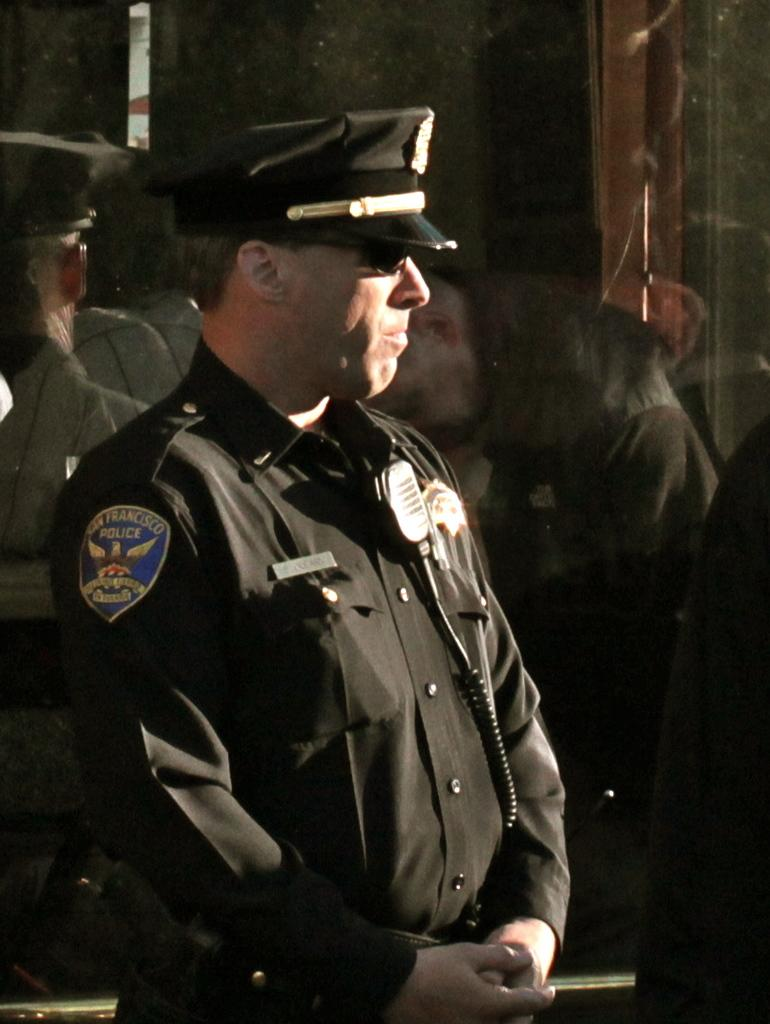Who is the main subject in the image? There is a person in the center of the image. What is the person wearing? The person is wearing a uniform. What is the person's posture in the image? The person is standing. What can be seen in the background of the image? There is a glass in the background of the image. What is reflected on the glass? The reflection of some persons is visible on the glass. How many centimeters is the zipper on the person's uniform? There is no mention of a zipper on the person's uniform in the image. What year is depicted in the image? The image does not depict a specific year; it is a snapshot of a person standing in a uniform. 